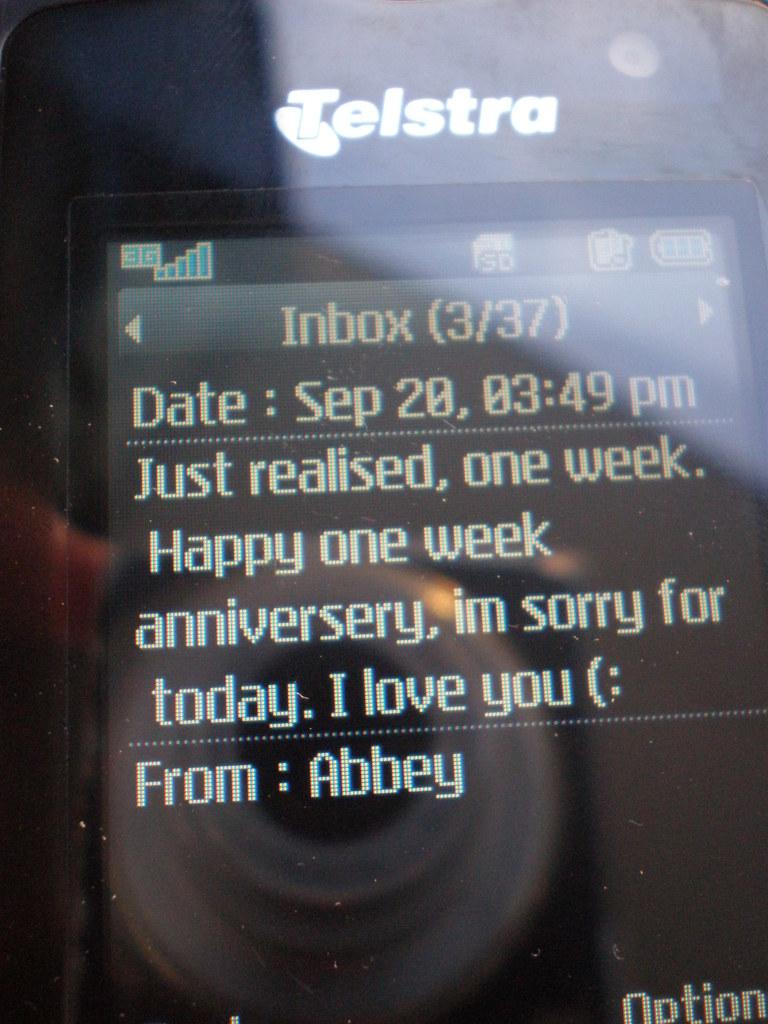<image>
Describe the image concisely. A text message that expresses an apology and wish the recipient a Happy one week anniversary. 